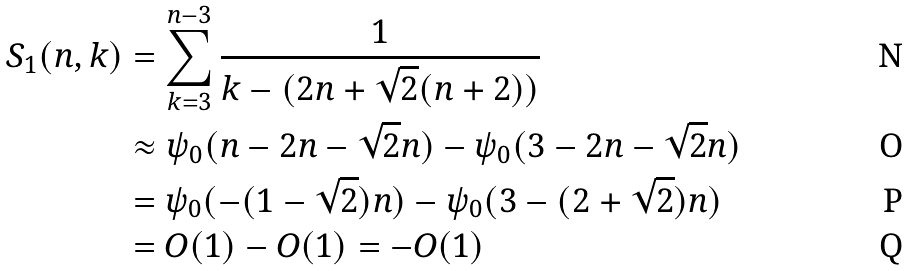Convert formula to latex. <formula><loc_0><loc_0><loc_500><loc_500>S _ { 1 } ( n , k ) & = \sum _ { k = 3 } ^ { n - 3 } \frac { 1 } { k - ( 2 n + \sqrt { 2 } ( n + 2 ) ) } \\ & \approx \psi _ { 0 } ( n - 2 n - \sqrt { 2 } n ) - \psi _ { 0 } ( 3 - 2 n - \sqrt { 2 } n ) \\ & = \psi _ { 0 } ( - ( 1 - \sqrt { 2 } ) n ) - \psi _ { 0 } ( 3 - ( 2 + \sqrt { 2 } ) n ) \\ & = O ( 1 ) - O ( 1 ) = - O ( 1 )</formula> 